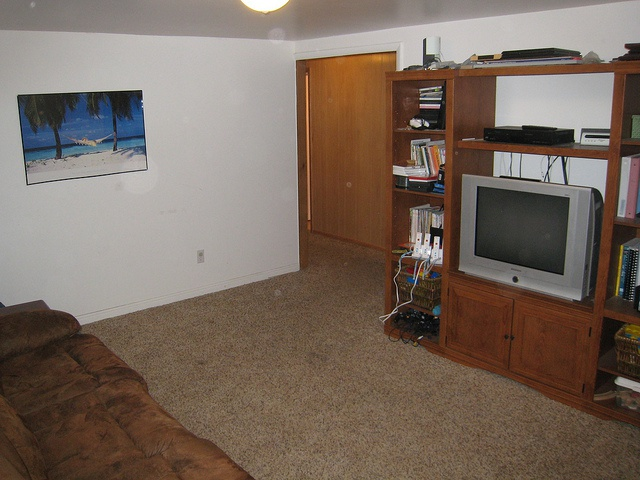Describe the objects in this image and their specific colors. I can see couch in gray, maroon, and black tones, tv in gray and black tones, book in gray, darkgray, brown, and red tones, book in gray, lightgray, darkgray, and black tones, and book in gray, darkgray, and lightgray tones in this image. 